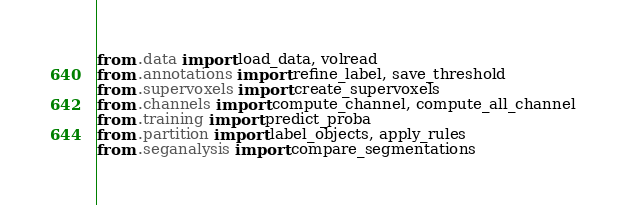Convert code to text. <code><loc_0><loc_0><loc_500><loc_500><_Python_>

from .data import load_data, volread
from .annotations import refine_label, save_threshold
from .supervoxels import create_supervoxels
from .channels import compute_channel, compute_all_channel
from .training import predict_proba
from .partition import label_objects, apply_rules
from .seganalysis import compare_segmentations</code> 